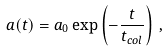<formula> <loc_0><loc_0><loc_500><loc_500>a ( t ) = a _ { 0 } \exp \left ( - \frac { t } { t _ { c o l } } \right ) \, ,</formula> 